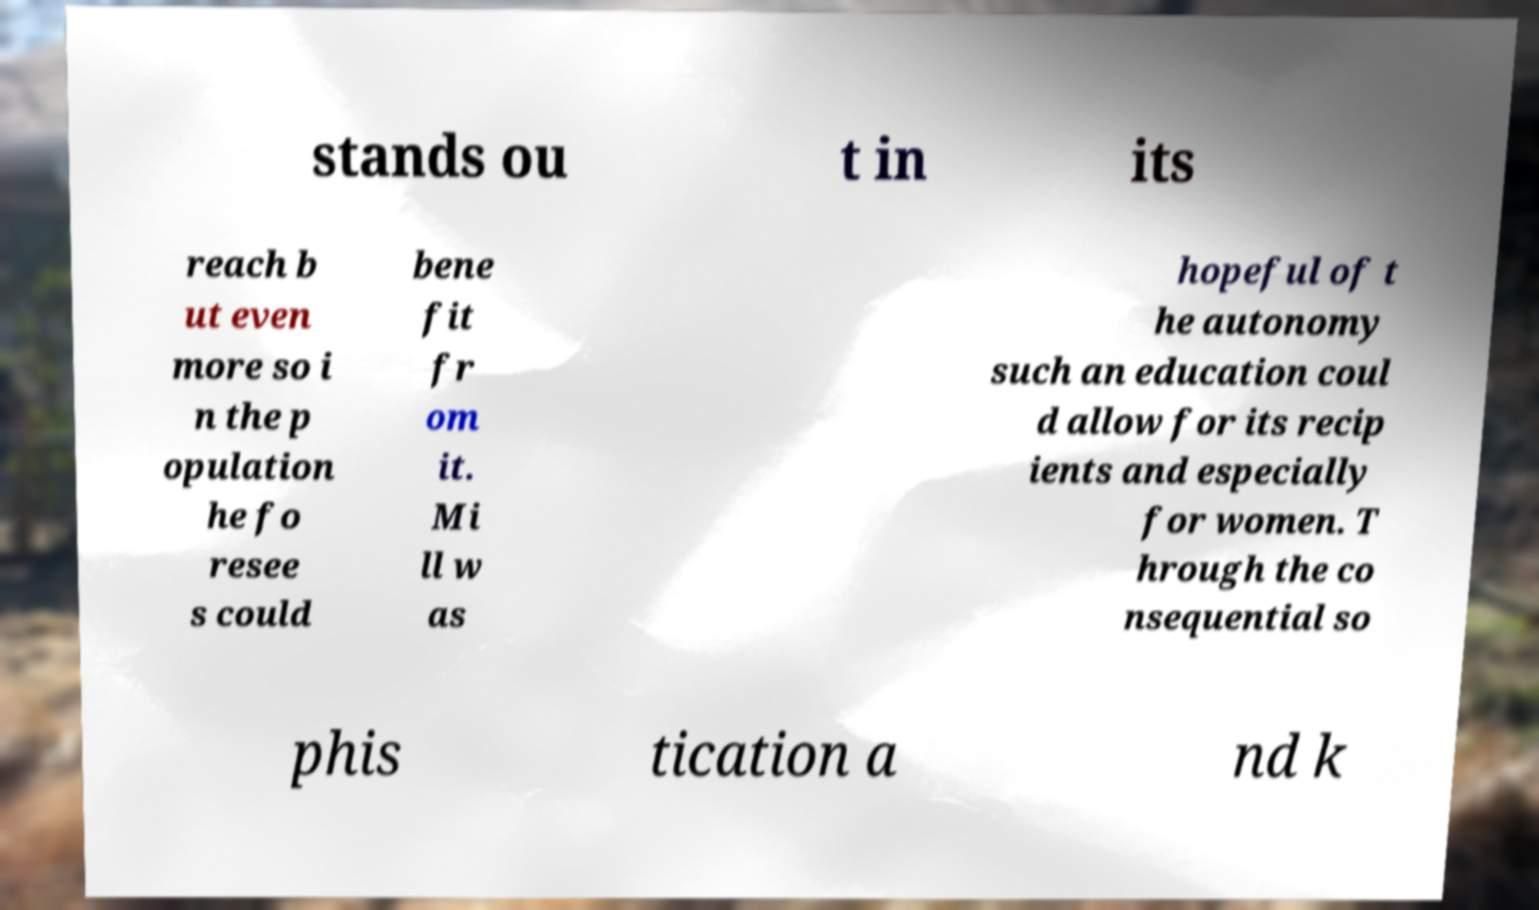Could you assist in decoding the text presented in this image and type it out clearly? stands ou t in its reach b ut even more so i n the p opulation he fo resee s could bene fit fr om it. Mi ll w as hopeful of t he autonomy such an education coul d allow for its recip ients and especially for women. T hrough the co nsequential so phis tication a nd k 